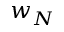<formula> <loc_0><loc_0><loc_500><loc_500>w _ { N }</formula> 